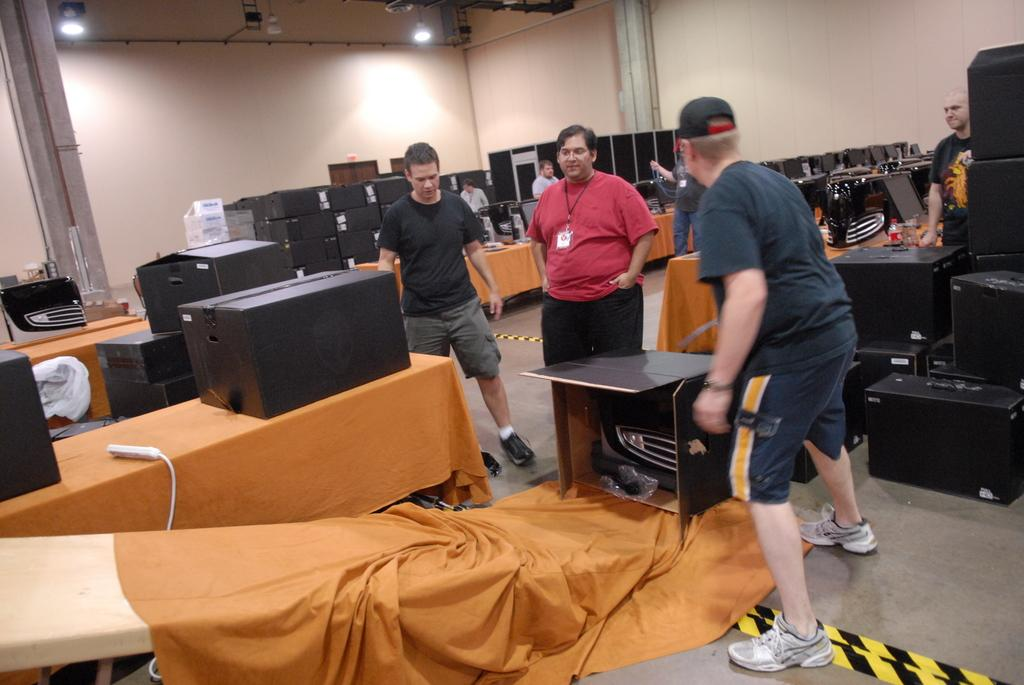What is the main subject of the image? The main subject of the image is multiple boxes. Can you describe the arrangement or positioning of the boxes? The boxes are in front of something else, possibly other objects or a background. How many men are holding the boxes in the image? There is no mention of men or anyone holding the boxes in the image. The boxes are simply present in the image. 